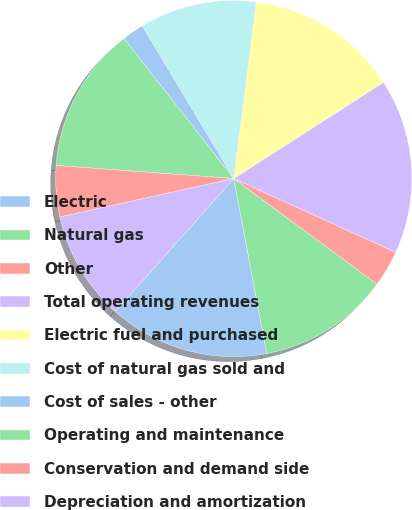Convert chart to OTSL. <chart><loc_0><loc_0><loc_500><loc_500><pie_chart><fcel>Electric<fcel>Natural gas<fcel>Other<fcel>Total operating revenues<fcel>Electric fuel and purchased<fcel>Cost of natural gas sold and<fcel>Cost of sales - other<fcel>Operating and maintenance<fcel>Conservation and demand side<fcel>Depreciation and amortization<nl><fcel>14.57%<fcel>11.92%<fcel>3.31%<fcel>15.89%<fcel>13.91%<fcel>10.6%<fcel>1.99%<fcel>13.25%<fcel>4.64%<fcel>9.93%<nl></chart> 